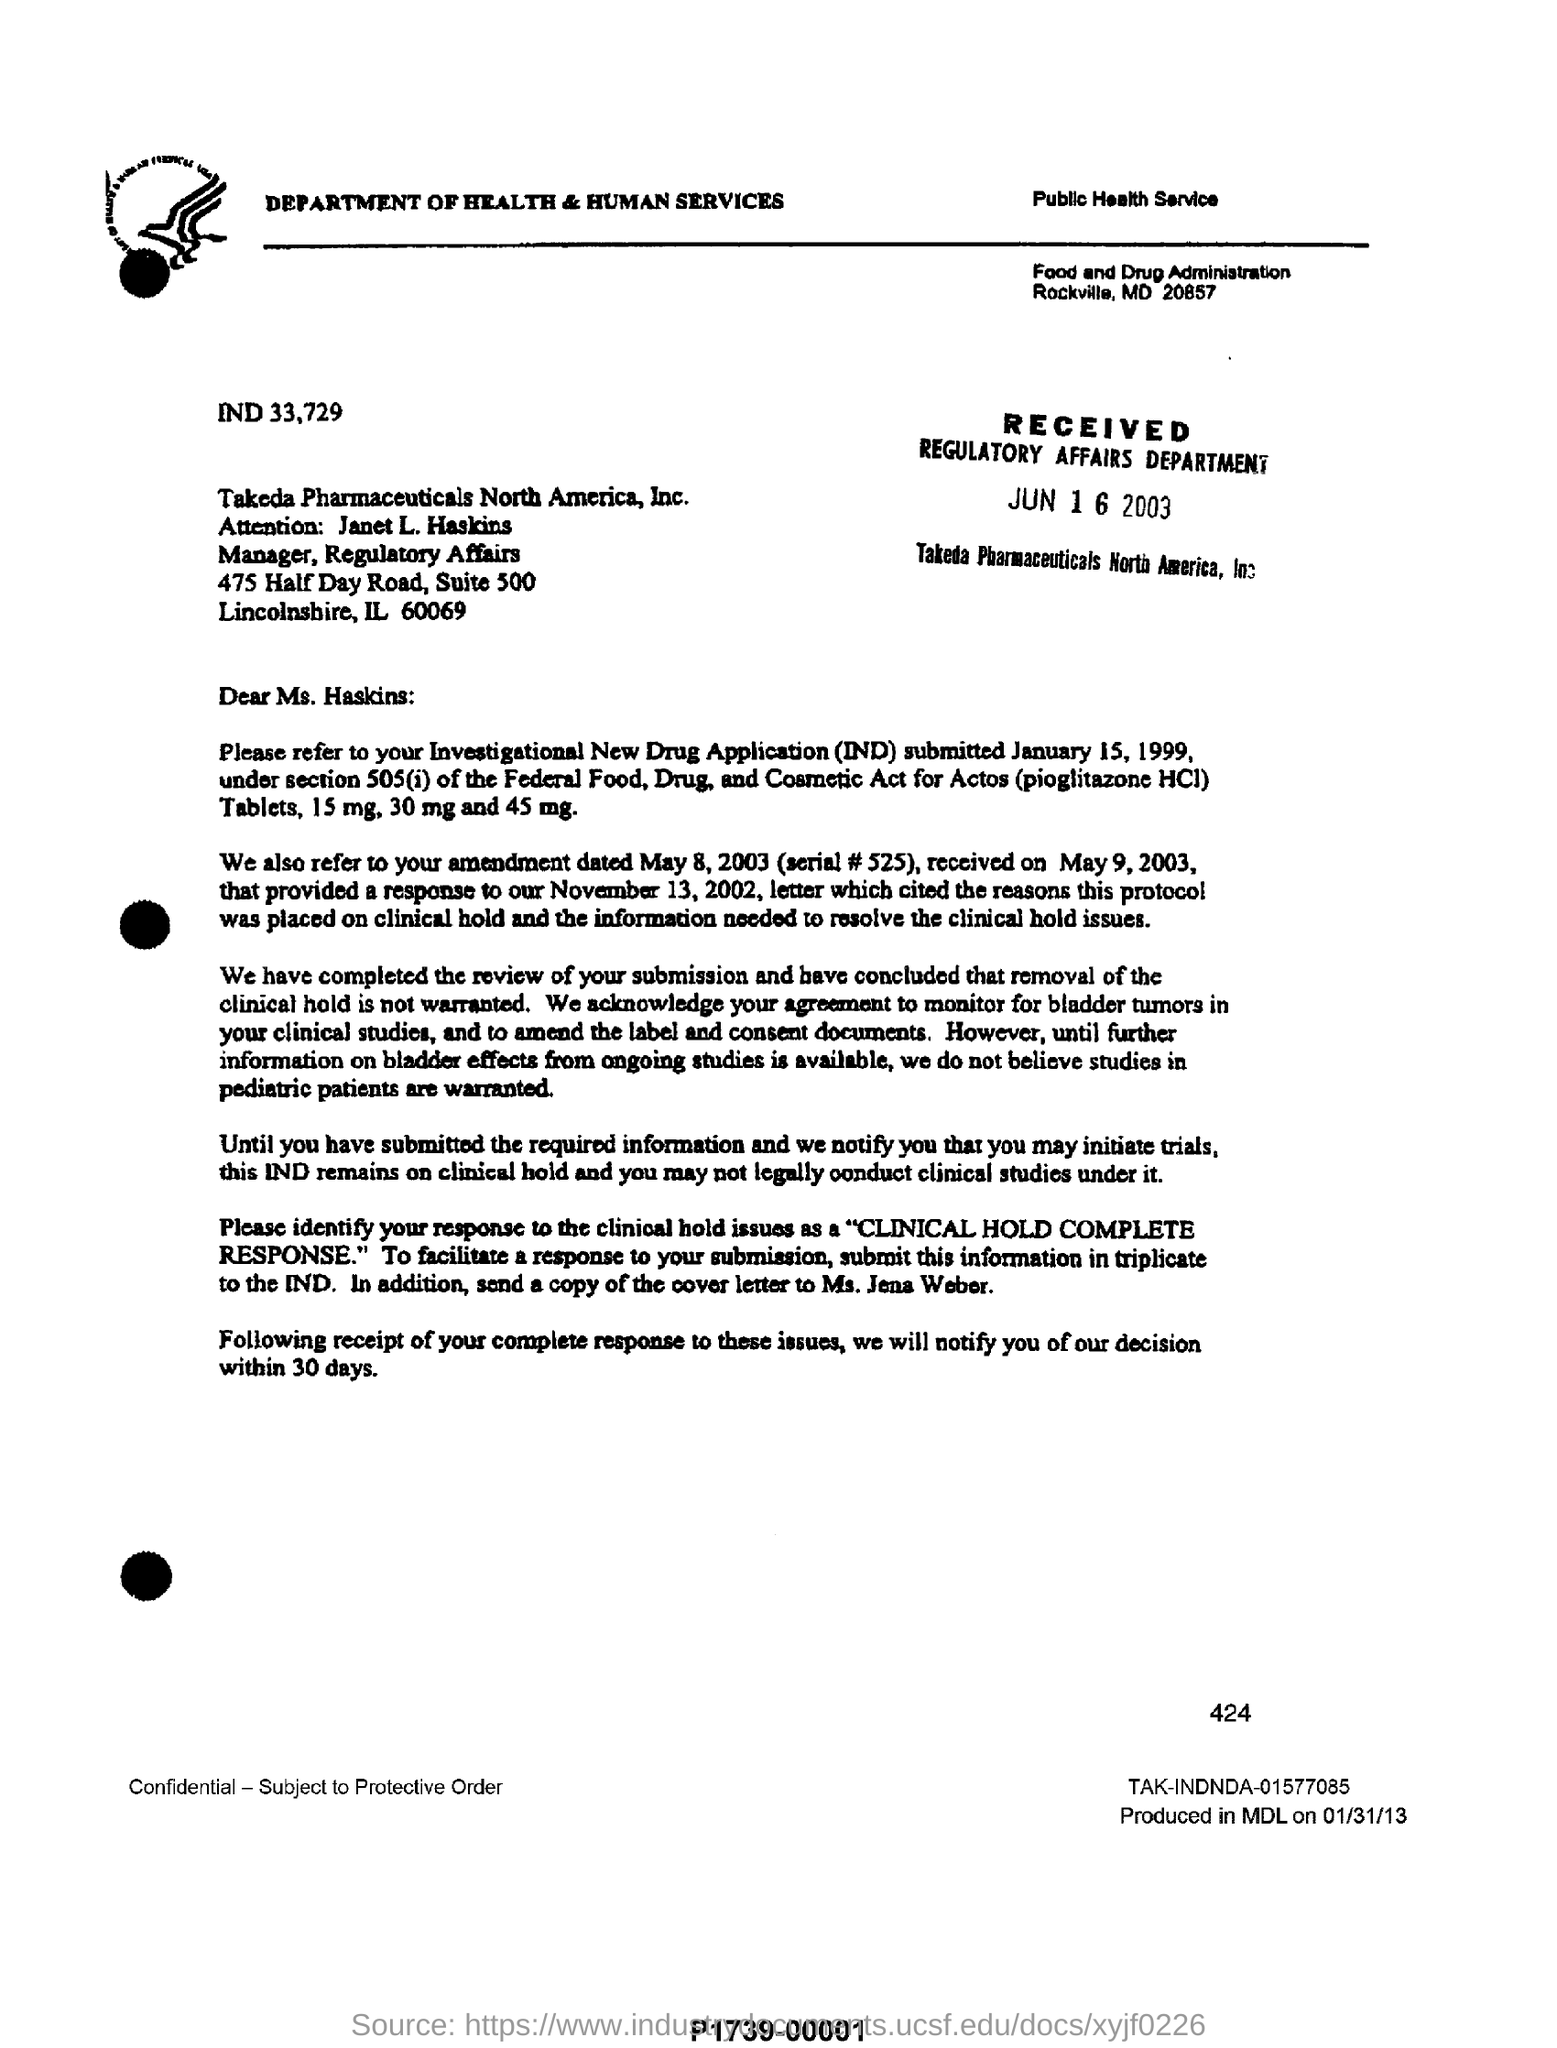Mention a couple of crucial points in this snapshot. The copy of the cover letter should be sent to Ms. Jens Weber. Takeda Pharmaceuticals North America, Inc. is a pharmaceutical company known for its name. On June 16, 2003, the Regulatory Affairs department received the letter. 